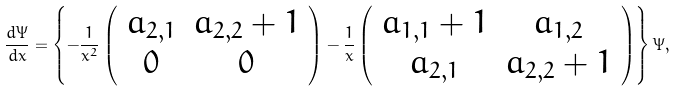<formula> <loc_0><loc_0><loc_500><loc_500>\frac { d \Psi } { d x } = \left \{ - \frac { 1 } { x ^ { 2 } } \left ( \begin{array} { c c } a _ { 2 , 1 } & a _ { 2 , 2 } + 1 \\ 0 & 0 \end{array} \right ) - \frac { 1 } { x } \left ( \begin{array} { c c } a _ { 1 , 1 } + 1 & a _ { 1 , 2 } \\ a _ { 2 , 1 } & a _ { 2 , 2 } + 1 \end{array} \right ) \right \} \Psi ,</formula> 